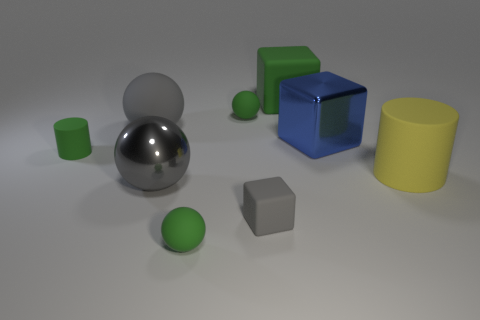Does the rubber cube in front of the large green thing have the same size as the metal thing on the right side of the small gray object?
Offer a terse response. No. How big is the gray matte thing that is to the right of the rubber ball that is in front of the large metal thing that is in front of the small green cylinder?
Your answer should be compact. Small. What is the shape of the gray object that is on the right side of the green ball that is in front of the big cube in front of the large green cube?
Provide a succinct answer. Cube. There is a matte object to the right of the green cube; what is its shape?
Your answer should be very brief. Cylinder. Are the tiny cylinder and the tiny green object that is in front of the small cube made of the same material?
Ensure brevity in your answer.  Yes. How many other objects are there of the same shape as the big green thing?
Give a very brief answer. 2. There is a tiny cylinder; is it the same color as the matte ball in front of the metal ball?
Your response must be concise. Yes. There is a matte object that is left of the gray rubber object that is behind the tiny green rubber cylinder; what is its shape?
Provide a succinct answer. Cylinder. There is a rubber cube that is the same color as the small cylinder; what size is it?
Make the answer very short. Large. Do the gray object that is behind the big cylinder and the big gray shiny object have the same shape?
Your answer should be compact. Yes. 